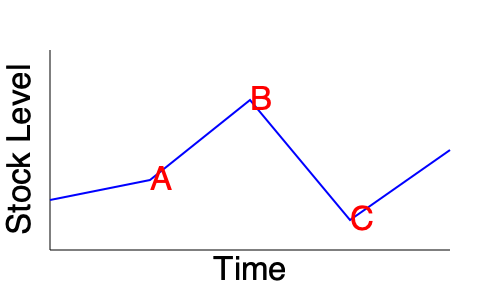Based on the stock level graph over time, which inventory management strategy would be most appropriate to implement at point C to optimize inventory levels and minimize holding costs? To determine the most appropriate inventory management strategy at point C, we need to analyze the graph and understand the inventory trends:

1. Observe the overall trend: The stock level fluctuates over time, with significant variations.

2. Analyze point C:
   - It represents a high stock level, following a sharp increase from point B.
   - This sudden increase suggests a potential overstock situation.

3. Consider the implications:
   - High stock levels lead to increased holding costs.
   - Overstocking ties up capital and may result in obsolescence.

4. Evaluate potential strategies:
   a) Just-in-Time (JIT): Not suitable due to the current high stock level.
   b) Economic Order Quantity (EOQ): Could help balance ordering and holding costs, but doesn't address the immediate overstock.
   c) ABC Analysis: Useful for categorizing inventory, but doesn't directly address the current situation.
   d) Vendor-Managed Inventory (VMI): Could help in the long term, but doesn't solve the immediate issue.
   e) Lean Inventory Management: This strategy focuses on reducing waste and excess inventory.

5. Conclusion:
   Lean Inventory Management would be the most appropriate strategy to implement at point C. It would help reduce the excess stock, minimize holding costs, and streamline the inventory to match demand more closely.

This strategy would involve:
- Identifying and eliminating excess inventory
- Improving forecasting accuracy
- Implementing pull-based systems
- Enhancing supplier relationships for more frequent, smaller deliveries

By applying Lean Inventory Management, the manufacturer can bring the stock level down to a more optimal point, reducing costs and improving efficiency.
Answer: Lean Inventory Management 